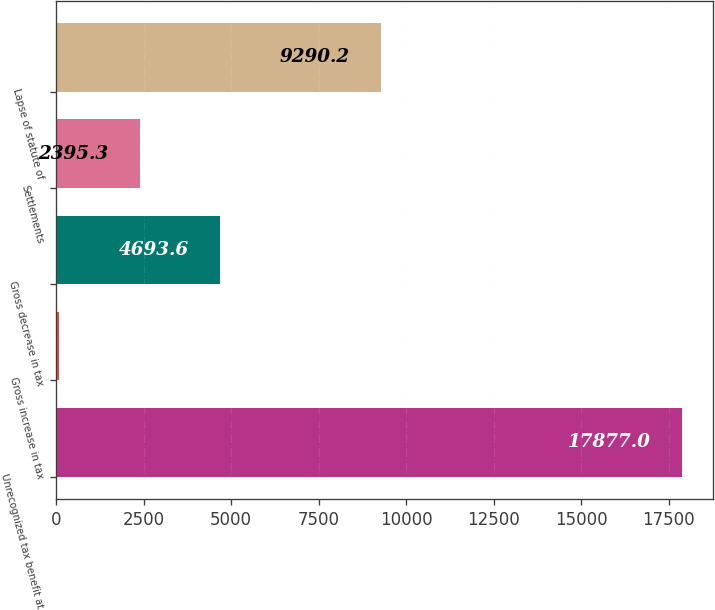<chart> <loc_0><loc_0><loc_500><loc_500><bar_chart><fcel>Unrecognized tax benefit at<fcel>Gross increase in tax<fcel>Gross decrease in tax<fcel>Settlements<fcel>Lapse of statute of<nl><fcel>17877<fcel>97<fcel>4693.6<fcel>2395.3<fcel>9290.2<nl></chart> 